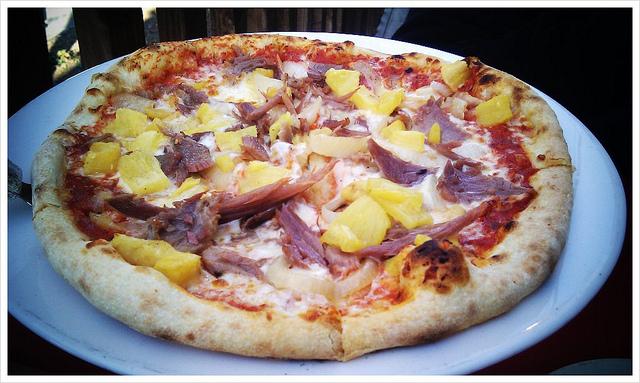How many different toppings are easily found?
Quick response, please. 2. Has any of the pizza been eaten?
Concise answer only. No. What fruit is on the pizza?
Quick response, please. Pineapple. 